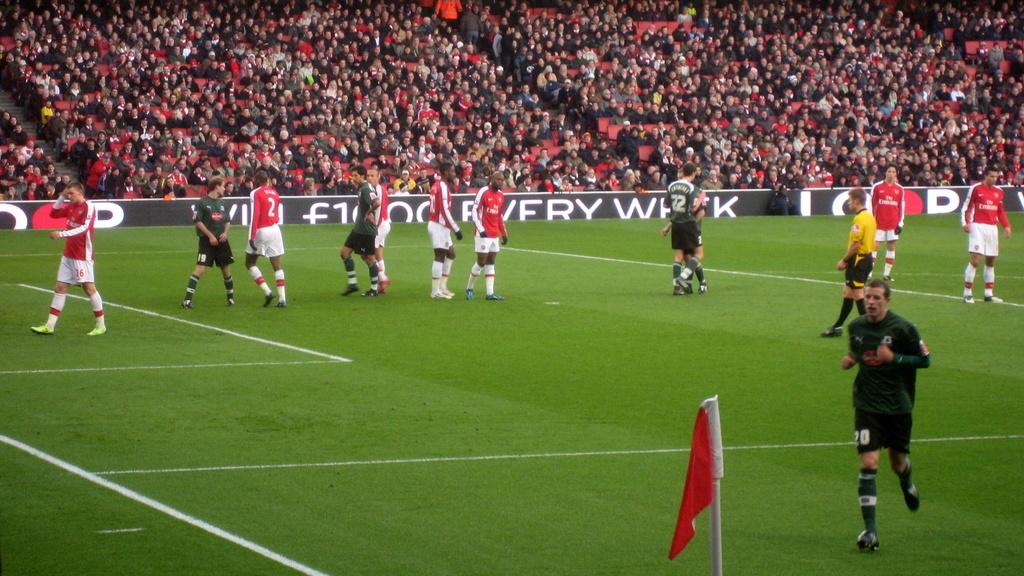<image>
Provide a brief description of the given image. Number sixteen is walking down the field rubbing his head with his right hand. 